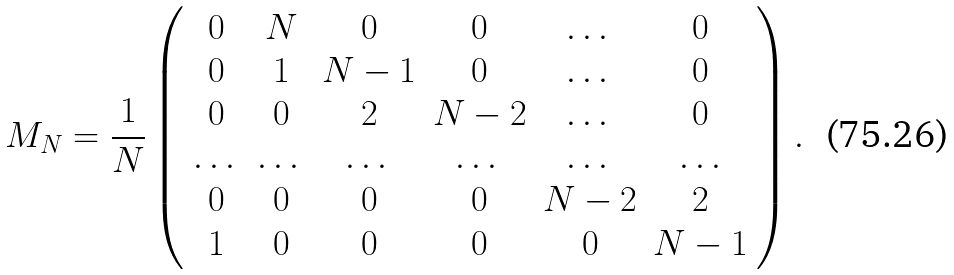<formula> <loc_0><loc_0><loc_500><loc_500>M _ { N } = \frac { 1 } { N } \left ( \begin{array} { c c c c c c } 0 & N & 0 & 0 & \dots & 0 \\ 0 & 1 & N - 1 & 0 & \dots & 0 \\ 0 & 0 & 2 & N - 2 & \dots & 0 \\ \dots & \dots & \dots & \dots & \dots & \dots \\ 0 & 0 & 0 & 0 & N - 2 & 2 \\ 1 & 0 & 0 & 0 & 0 & N - 1 \end{array} \right ) .</formula> 